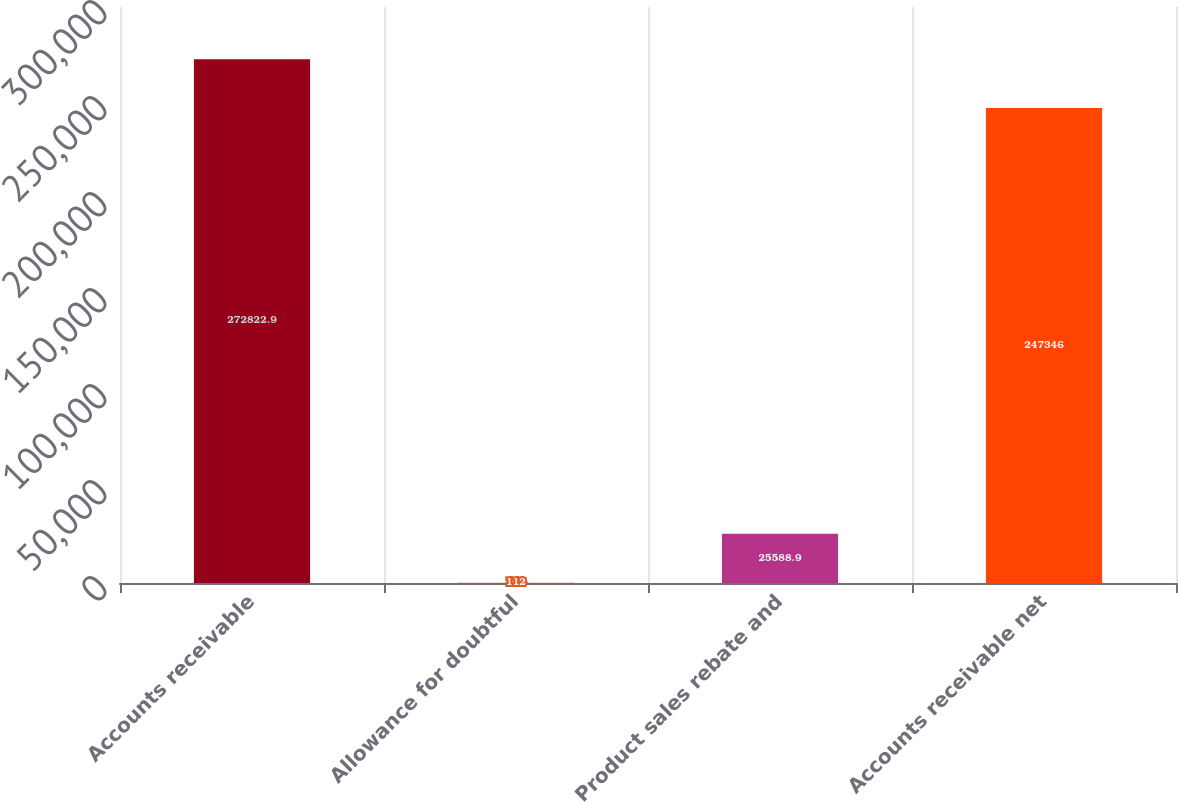<chart> <loc_0><loc_0><loc_500><loc_500><bar_chart><fcel>Accounts receivable<fcel>Allowance for doubtful<fcel>Product sales rebate and<fcel>Accounts receivable net<nl><fcel>272823<fcel>112<fcel>25588.9<fcel>247346<nl></chart> 